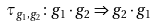Convert formula to latex. <formula><loc_0><loc_0><loc_500><loc_500>\tau _ { g _ { 1 } , g _ { 2 } } \colon g _ { 1 } \cdot g _ { 2 } \Rightarrow g _ { 2 } \cdot g _ { 1 }</formula> 